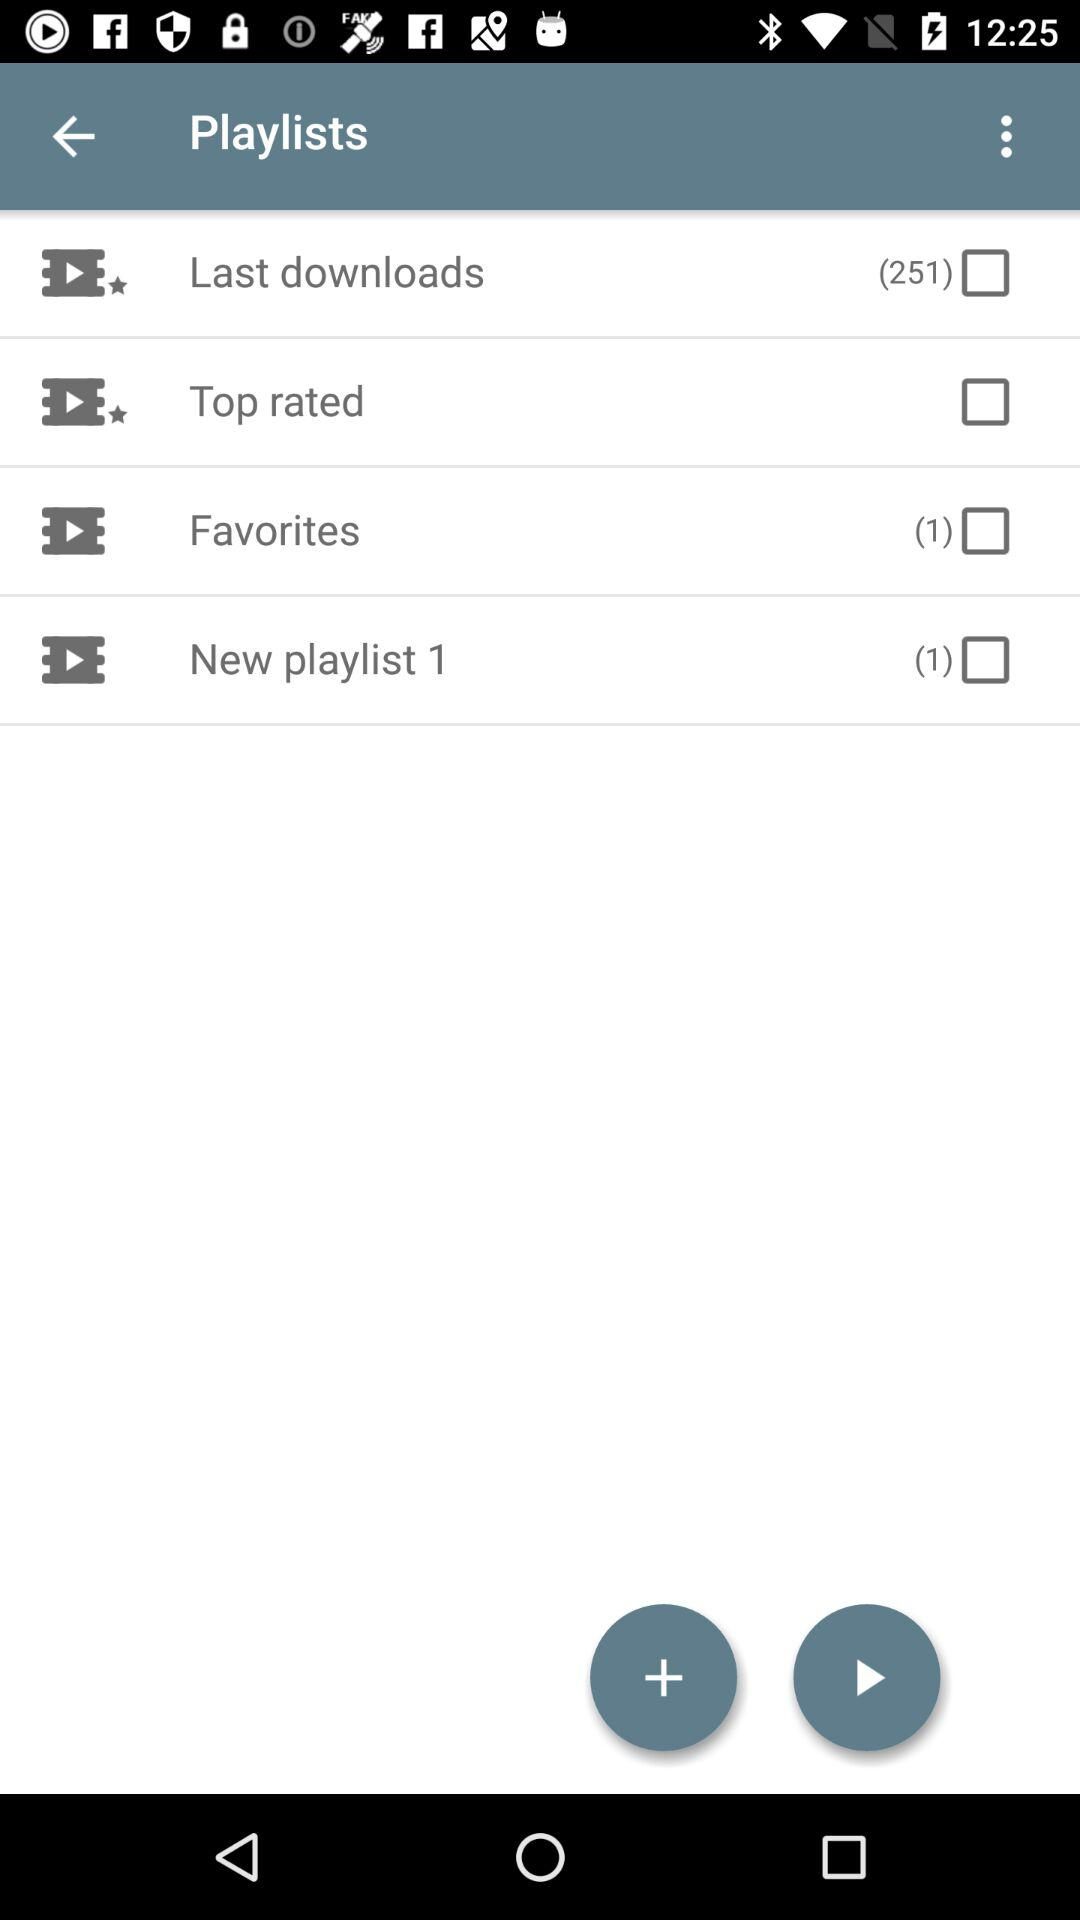How many "Favorites" in total are there? The total number of "Favorites" is 1. 